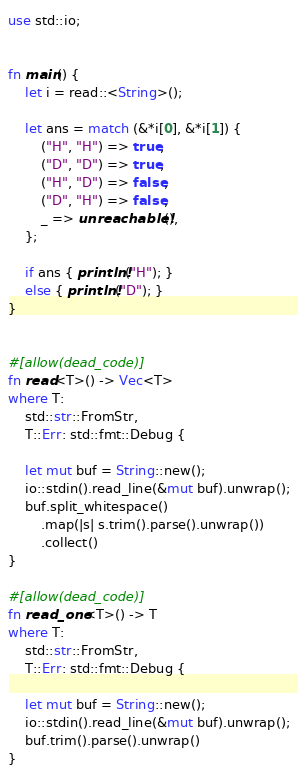<code> <loc_0><loc_0><loc_500><loc_500><_Rust_>use std::io;


fn main() {
    let i = read::<String>();

    let ans = match (&*i[0], &*i[1]) {
        ("H", "H") => true,
        ("D", "D") => true,
        ("H", "D") => false,
        ("D", "H") => false,
        _ => unreachable!(),
    };

    if ans { println!("H"); }
    else { println!("D"); }
}


#[allow(dead_code)]
fn read<T>() -> Vec<T>
where T:
    std::str::FromStr,
    T::Err: std::fmt::Debug {

    let mut buf = String::new();
    io::stdin().read_line(&mut buf).unwrap();
    buf.split_whitespace()
        .map(|s| s.trim().parse().unwrap())
        .collect()
}

#[allow(dead_code)]
fn read_one<T>() -> T
where T:
    std::str::FromStr,
    T::Err: std::fmt::Debug {

    let mut buf = String::new();
    io::stdin().read_line(&mut buf).unwrap();
    buf.trim().parse().unwrap()
}</code> 